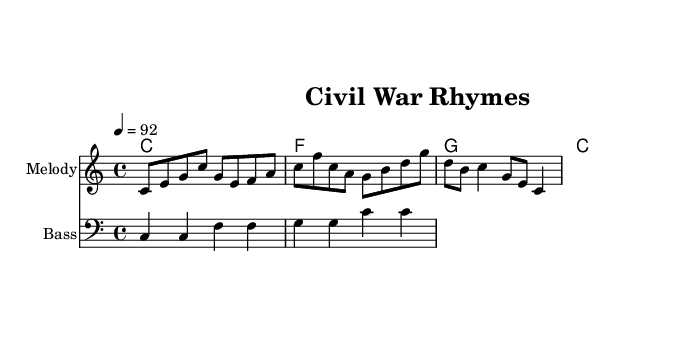What is the key signature of this music? The key signature is positioned at the beginning of the staff. It is C major, which has no sharps or flats indicated.
Answer: C major What is the time signature of this music? The time signature is found next to the key signature. It is 4/4, meaning there are four beats in each measure and a quarter note receives one beat.
Answer: 4/4 What is the tempo marking for this piece? The tempo marking can be found in the header section of the score. It indicates the piece should be played at a speed of 92 beats per minute.
Answer: 92 Which two key figures are mentioned in the lyrics? The lyrics contain the names of two prominent figures in the Civil War, clearly stated within the first line of the lyrics. They are Lincoln and Lee.
Answer: Lincoln and Lee How many measures are in the melody? The melody section consists of musical phrases arranged across 4 measures, evident by the structure of the notes and rhythmic values used.
Answer: 4 What is the main theme of the lyrics? The lyrics revolve around the themes of the Civil War, specifically mentioning key events like Gettysburg and the Emancipation, which signify the struggle and call for freedom.
Answer: Civil War 